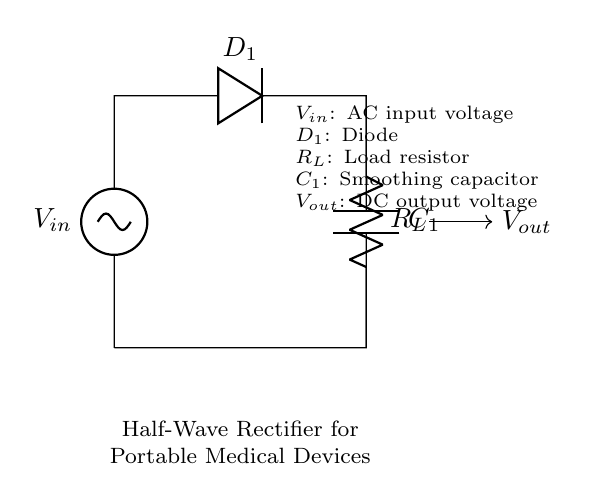what is the type of rectifier used in this circuit? This circuit diagram depicts a half-wave rectifier, which is specifically designed to convert alternating current into direct current by allowing only one half of the AC waveform to pass through.
Answer: half-wave rectifier what is the purpose of the diode in this circuit? The diode, labeled D1, is used to allow current to flow in one direction only, effectively blocking the negative half of the AC input voltage and allowing only the positive half to reach the load.
Answer: allow current flow in one direction what is the load in this rectifier circuit? The load in this circuit is represented by the resistor labeled R_L, which is where the converted DC voltage is applied in the circuit.
Answer: R_L what component smooths the output voltage? The smoothing capacitor, labeled C1, is used to reduce the ripple in the output voltage by storing charge and releasing it when the diode is not conducting.
Answer: C1 what is the function of the smoothing capacitor in this circuit? The smoothing capacitor, C1, filters the output by storing energy during the conduction phase and releasing it during the non-conduction phase, thus providing a steadier DC voltage to the load.
Answer: reduce output voltage ripple what happens to the output voltage when the input voltage increases? When the AC input voltage increases, the output voltage also increases, as it reflects the magnitude of the input during the positive half-cycle, minus the forward voltage drop of the diode.
Answer: increases what is the characteristic waveform of the output voltage in a half-wave rectifier? The output voltage characteristic waveform of a half-wave rectifier features a series of positive half-cycles corresponding to the positive input voltage, with zero voltage during the negative half-cycles.
Answer: positive half-cycles 